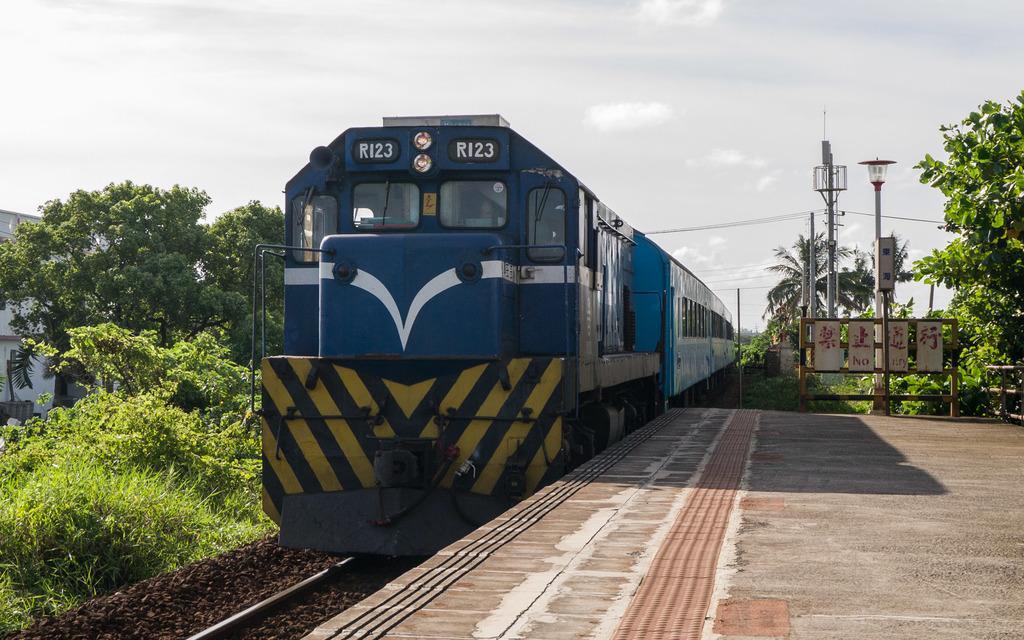How would you summarize this image in a sentence or two? This is an outside view. In the middle of this image there is a train on the railway track. On the right side there is a platform. On the left side there are many trees and a building. At the top of the image I can see the sky and clouds. On the right side there are some light poles. 